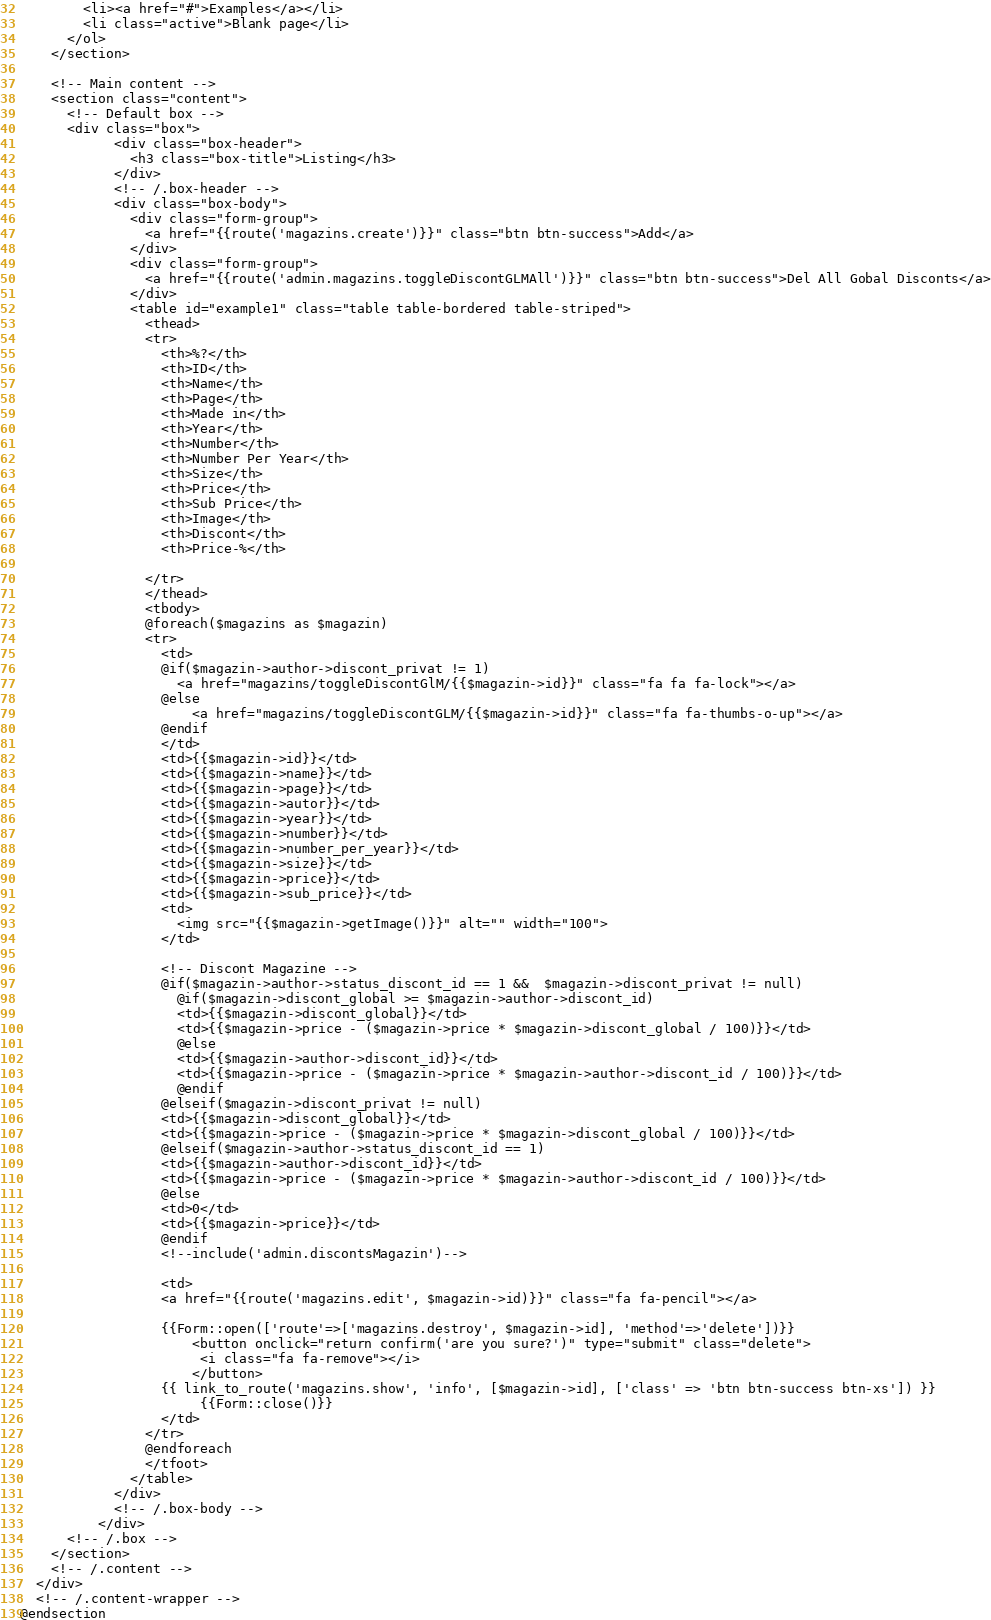<code> <loc_0><loc_0><loc_500><loc_500><_PHP_>        <li><a href="#">Examples</a></li>
        <li class="active">Blank page</li>
      </ol>
    </section>

    <!-- Main content -->
    <section class="content">
      <!-- Default box -->
      <div class="box">
            <div class="box-header">
              <h3 class="box-title">Listing</h3>
            </div>
            <!-- /.box-header -->
            <div class="box-body">
              <div class="form-group">
                <a href="{{route('magazins.create')}}" class="btn btn-success">Add</a>
              </div>
              <div class="form-group">
                <a href="{{route('admin.magazins.toggleDiscontGLMAll')}}" class="btn btn-success">Del All Gobal Disconts</a>
              </div>    
              <table id="example1" class="table table-bordered table-striped">
                <thead>
                <tr>
                  <th>%?</th>
                  <th>ID</th>
                  <th>Name</th>
                  <th>Page</th>
                  <th>Made in</th>
                  <th>Year</th>
                  <th>Number</th>
                  <th>Number Per Year</th>
                  <th>Size</th>
                  <th>Price</th>
                  <th>Sub Price</th>
                  <th>Image</th>
                  <th>Discont</th>
                  <th>Price-%</th>
                  
                </tr>
                </thead>
                <tbody>
                @foreach($magazins as $magazin)
                <tr>
                  <td>
                  @if($magazin->author->discont_privat != 1)
                    <a href="magazins/toggleDiscontGlM/{{$magazin->id}}" class="fa fa fa-lock"></a> 
                  @else
                      <a href="magazins/toggleDiscontGLM/{{$magazin->id}}" class="fa fa-thumbs-o-up"></a> 
                  @endif
                  </td>
                  <td>{{$magazin->id}}</td>
                  <td>{{$magazin->name}}</td>
                  <td>{{$magazin->page}}</td>
                  <td>{{$magazin->autor}}</td>                  
                  <td>{{$magazin->year}}</td>
                  <td>{{$magazin->number}}</td>
                  <td>{{$magazin->number_per_year}}</td>
                  <td>{{$magazin->size}}</td>
                  <td>{{$magazin->price}}</td>
                  <td>{{$magazin->sub_price}}</td>
                  <td>
                    <img src="{{$magazin->getImage()}}" alt="" width="100">
                  </td>
                    
                  <!-- Discont Magazine -->  
                  @if($magazin->author->status_discont_id == 1 &&  $magazin->discont_privat != null)
                    @if($magazin->discont_global >= $magazin->author->discont_id)
                    <td>{{$magazin->discont_global}}</td>
                    <td>{{$magazin->price - ($magazin->price * $magazin->discont_global / 100)}}</td>
                    @else
                    <td>{{$magazin->author->discont_id}}</td>
                    <td>{{$magazin->price - ($magazin->price * $magazin->author->discont_id / 100)}}</td>
                    @endif
                  @elseif($magazin->discont_privat != null)
                  <td>{{$magazin->discont_global}}</td>
                  <td>{{$magazin->price - ($magazin->price * $magazin->discont_global / 100)}}</td>
                  @elseif($magazin->author->status_discont_id == 1)
                  <td>{{$magazin->author->discont_id}}</td>
                  <td>{{$magazin->price - ($magazin->price * $magazin->author->discont_id / 100)}}</td>
                  @else
                  <td>0</td>
                  <td>{{$magazin->price}}</td>
                  @endif
                  <!--include('admin.discontsMagazin')-->
                  
                  <td>
                  <a href="{{route('magazins.edit', $magazin->id)}}" class="fa fa-pencil"></a> 

                  {{Form::open(['route'=>['magazins.destroy', $magazin->id], 'method'=>'delete'])}}
	                  <button onclick="return confirm('are you sure?')" type="submit" class="delete">
	                   <i class="fa fa-remove"></i>
	                  </button>
                  {{ link_to_route('magazins.show', 'info', [$magazin->id], ['class' => 'btn btn-success btn-xs']) }}
	                   {{Form::close()}}
                  </td>
                </tr>
                @endforeach
                </tfoot>
              </table>
            </div>
            <!-- /.box-body -->
          </div>
      <!-- /.box -->
    </section>
    <!-- /.content -->
  </div>
  <!-- /.content-wrapper -->
@endsection</code> 